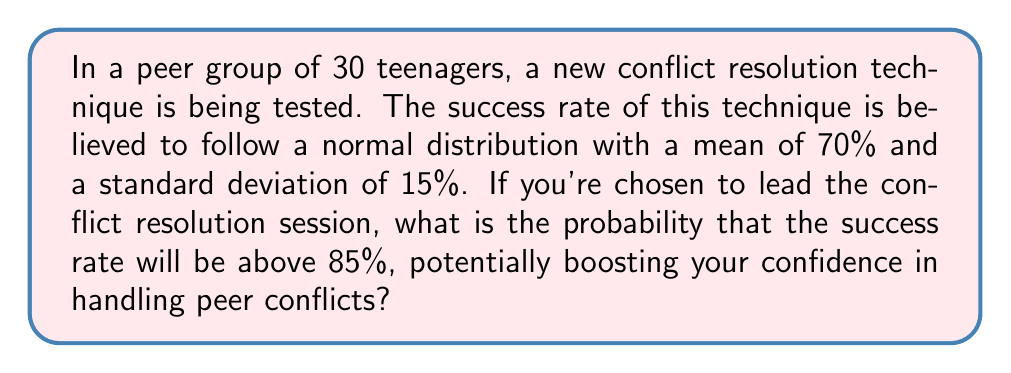Show me your answer to this math problem. Let's approach this step-by-step:

1) We are dealing with a normal distribution where:
   Mean (μ) = 70%
   Standard deviation (σ) = 15%

2) We want to find the probability of the success rate being above 85%.

3) To do this, we need to calculate the z-score for 85%:

   $$ z = \frac{x - μ}{σ} $$

   Where x is our value of interest (85%)

4) Plugging in the values:

   $$ z = \frac{85 - 70}{15} = 1 $$

5) Now we need to find the probability of a z-score being greater than 1.

6) Using a standard normal distribution table or calculator, we find:

   P(Z > 1) ≈ 0.1587

7) Therefore, the probability of the success rate being above 85% is approximately 0.1587 or 15.87%.

This means there's about a 15.87% chance that the success rate will be above 85%, which might make you a bit nervous as it's not very likely, but remember that even a lower success rate can still be valuable in resolving conflicts.
Answer: 0.1587 or 15.87% 